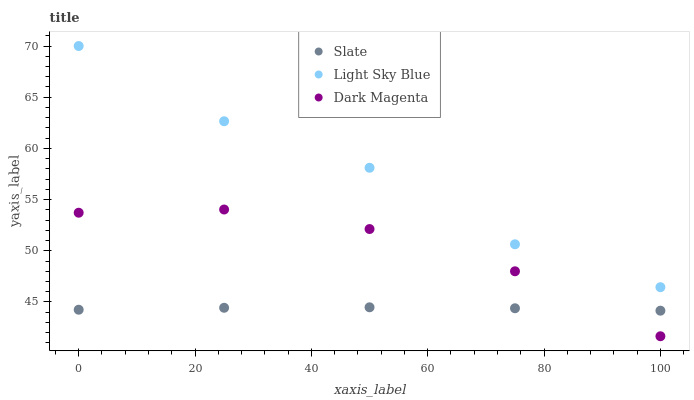Does Slate have the minimum area under the curve?
Answer yes or no. Yes. Does Light Sky Blue have the maximum area under the curve?
Answer yes or no. Yes. Does Dark Magenta have the minimum area under the curve?
Answer yes or no. No. Does Dark Magenta have the maximum area under the curve?
Answer yes or no. No. Is Slate the smoothest?
Answer yes or no. Yes. Is Light Sky Blue the roughest?
Answer yes or no. Yes. Is Dark Magenta the smoothest?
Answer yes or no. No. Is Dark Magenta the roughest?
Answer yes or no. No. Does Dark Magenta have the lowest value?
Answer yes or no. Yes. Does Light Sky Blue have the lowest value?
Answer yes or no. No. Does Light Sky Blue have the highest value?
Answer yes or no. Yes. Does Dark Magenta have the highest value?
Answer yes or no. No. Is Dark Magenta less than Light Sky Blue?
Answer yes or no. Yes. Is Light Sky Blue greater than Dark Magenta?
Answer yes or no. Yes. Does Dark Magenta intersect Slate?
Answer yes or no. Yes. Is Dark Magenta less than Slate?
Answer yes or no. No. Is Dark Magenta greater than Slate?
Answer yes or no. No. Does Dark Magenta intersect Light Sky Blue?
Answer yes or no. No. 